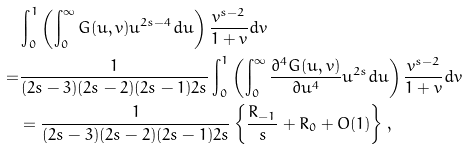Convert formula to latex. <formula><loc_0><loc_0><loc_500><loc_500>& \int _ { 0 } ^ { 1 } \left ( \int _ { 0 } ^ { \infty } G ( u , v ) u ^ { 2 s - 4 } d u \right ) \frac { v ^ { s - 2 } } { 1 + v } d v \\ = & \frac { 1 } { ( 2 s - 3 ) ( 2 s - 2 ) ( 2 s - 1 ) 2 s } \int _ { 0 } ^ { 1 } \left ( \int _ { 0 } ^ { \infty } \frac { \partial ^ { 4 } G ( u , v ) } { \partial u ^ { 4 } } u ^ { 2 s } d u \right ) \frac { v ^ { s - 2 } } { 1 + v } d v \\ & = \frac { 1 } { ( 2 s - 3 ) ( 2 s - 2 ) ( 2 s - 1 ) 2 s } \left \{ \frac { R _ { - 1 } } { s } + R _ { 0 } + O ( 1 ) \right \} ,</formula> 